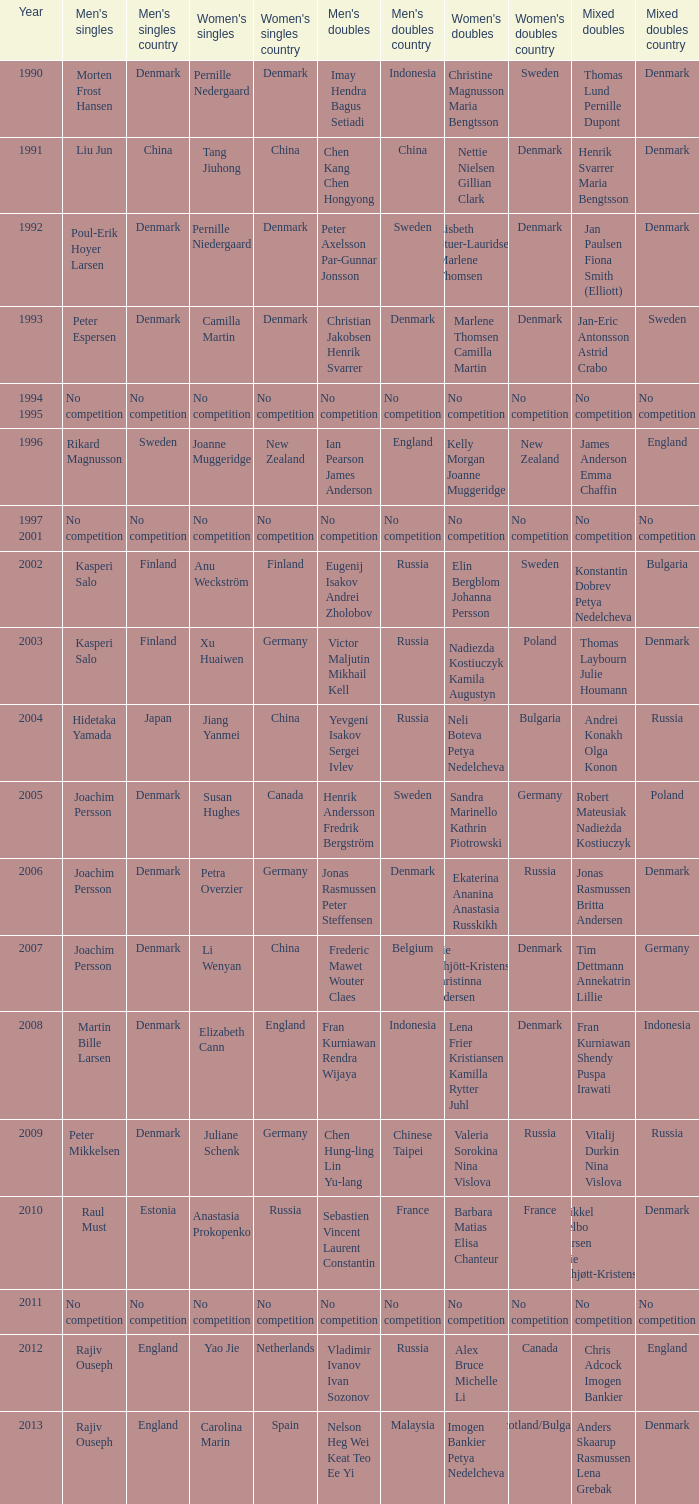Who won the Mixed Doubles in 2007? Tim Dettmann Annekatrin Lillie. 